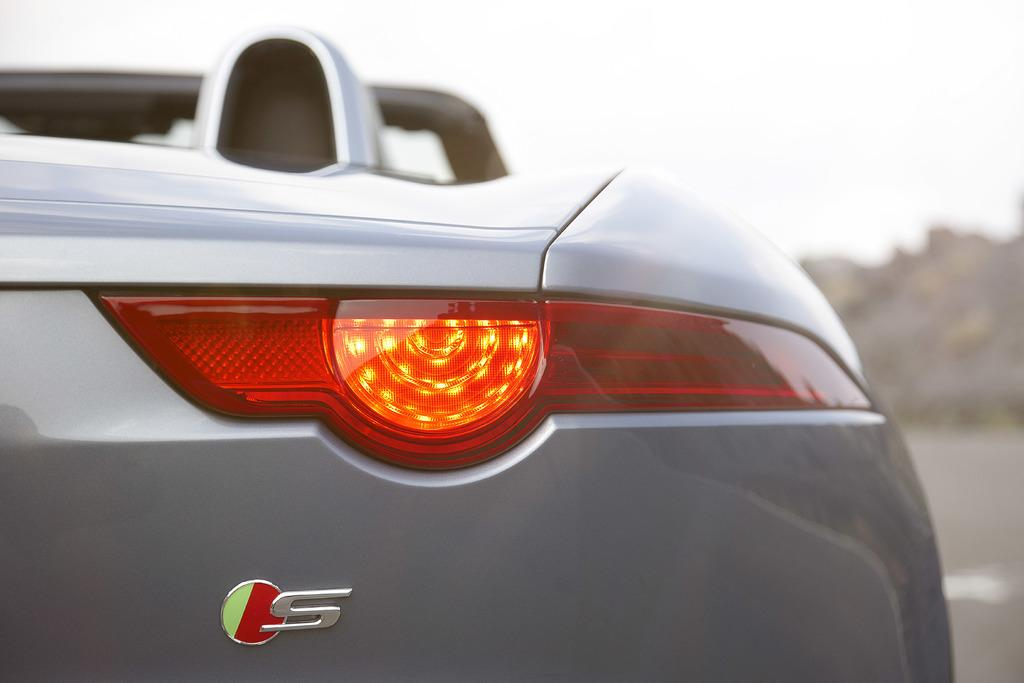What is the main subject of the image? There is a vehicle in the image. From which angle is the vehicle shown? The view of the vehicle is from the back side. How would you describe the background of the image? The background of the image is blurred. What type of organization is depicted in the image? There is no organization depicted in the image; it features a vehicle from the back side with a blurred background. Can you see a scarecrow in the image? There is no scarecrow present in the image. 